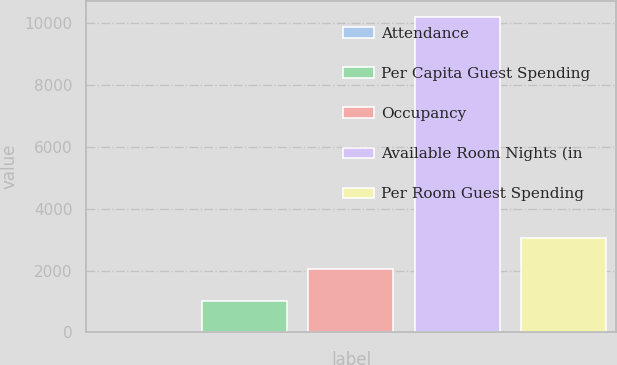Convert chart to OTSL. <chart><loc_0><loc_0><loc_500><loc_500><bar_chart><fcel>Attendance<fcel>Per Capita Guest Spending<fcel>Occupancy<fcel>Available Room Nights (in<fcel>Per Room Guest Spending<nl><fcel>2<fcel>1022.3<fcel>2042.6<fcel>10205<fcel>3062.9<nl></chart> 